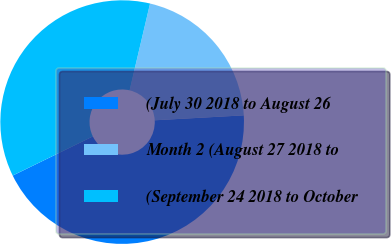Convert chart. <chart><loc_0><loc_0><loc_500><loc_500><pie_chart><fcel>(July 30 2018 to August 26<fcel>Month 2 (August 27 2018 to<fcel>(September 24 2018 to October<nl><fcel>43.65%<fcel>20.44%<fcel>35.91%<nl></chart> 